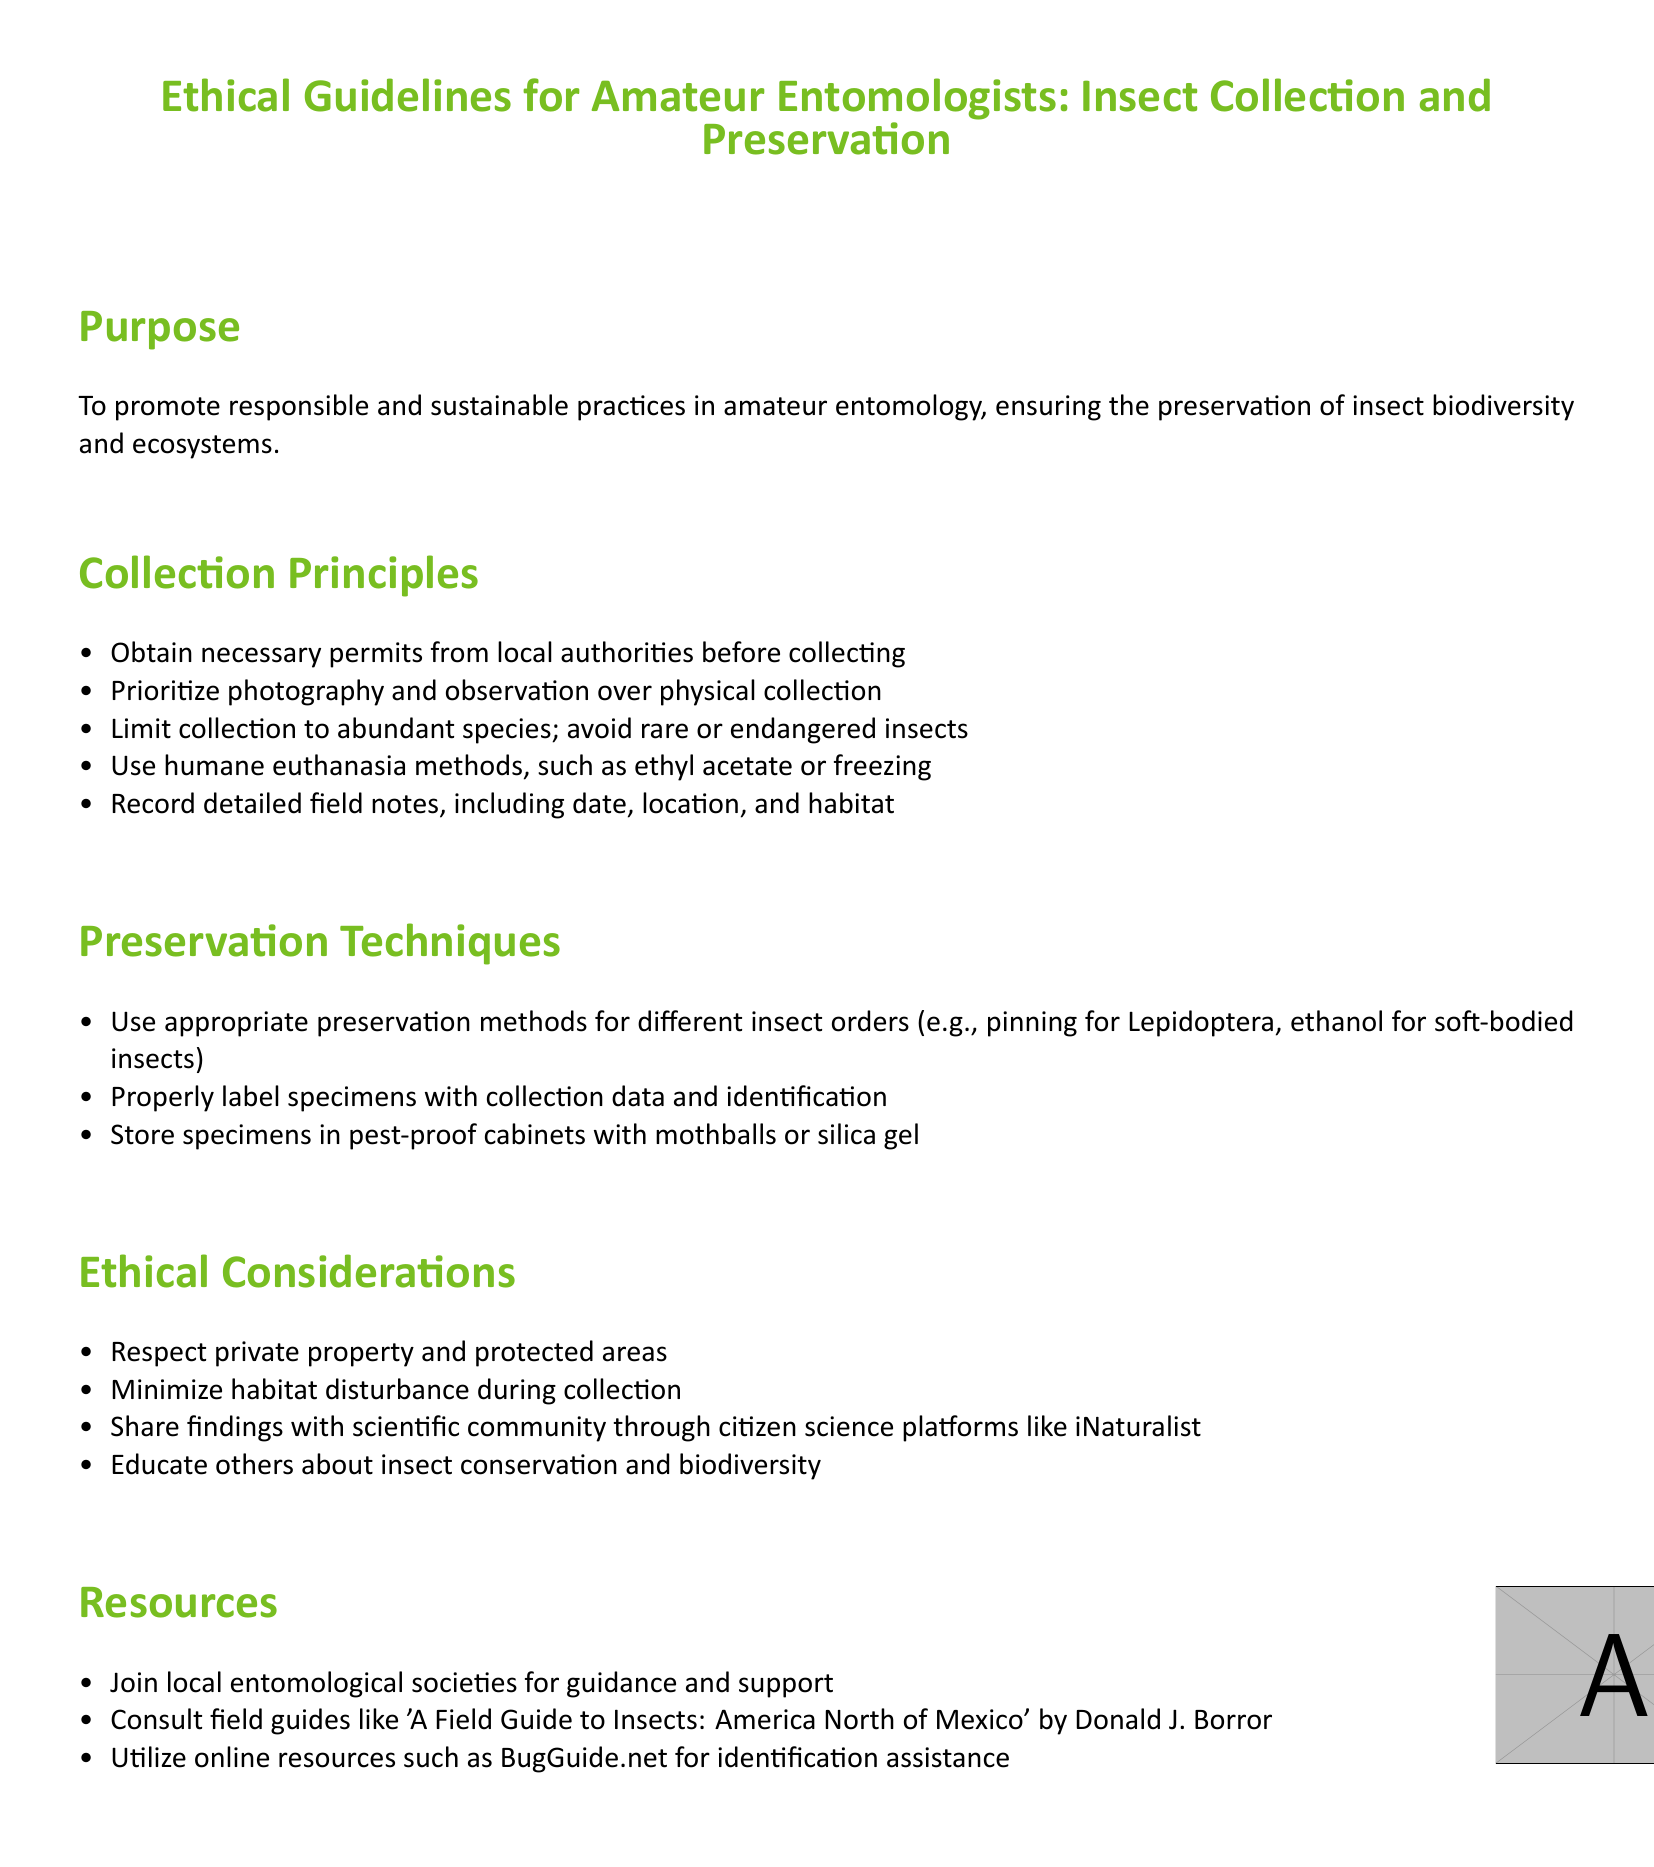What is the purpose of the guidelines? The purpose of the guidelines is stated at the beginning, focusing on promoting responsible and sustainable practices in amateur entomology.
Answer: To promote responsible and sustainable practices in amateur entomology, ensuring the preservation of insect biodiversity and ecosystems What should be prioritized over physical collection? The document mentions prioritizing specific activities in the Collection Principles section.
Answer: Photography and observation What methods are suggested for humane euthanasia? The guidelines provide specific euthanasia methods under the Collection Principles.
Answer: Ethyl acetate or freezing What should be used to preserve soft-bodied insects? The Preservation Techniques section specifies preservation methods for different insect orders.
Answer: Ethanol Which online resource is recommended for identification assistance? The Resources section lists useful online platforms for entomologists.
Answer: BugGuide.net What is one ethical consideration mentioned in the document? The Ethical Considerations section outlines various ethical principles.
Answer: Respect private property How can one educate others about insect conservation? The document encourages sharing knowledge on insect conservation through various means in the Ethical Considerations section.
Answer: Educate others about insect conservation and biodiversity What supports local entomologists in collecting insects? The Resources section provides various suggestions for local entomologists.
Answer: Join local entomological societies Which field guide is recommended for insects in North America? A specific field guide is mentioned in the Resources section for guidance.
Answer: A Field Guide to Insects: America North of Mexico 